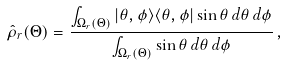Convert formula to latex. <formula><loc_0><loc_0><loc_500><loc_500>\hat { \rho } _ { r } ( \Theta ) = \frac { \int _ { \Omega _ { r } ( \Theta ) } | \theta , \phi \rangle \langle \theta , \phi | \sin \theta \, d \theta \, d \phi } { \int _ { \Omega _ { r } ( \Theta ) } \sin \theta \, d \theta \, d \phi } \, ,</formula> 